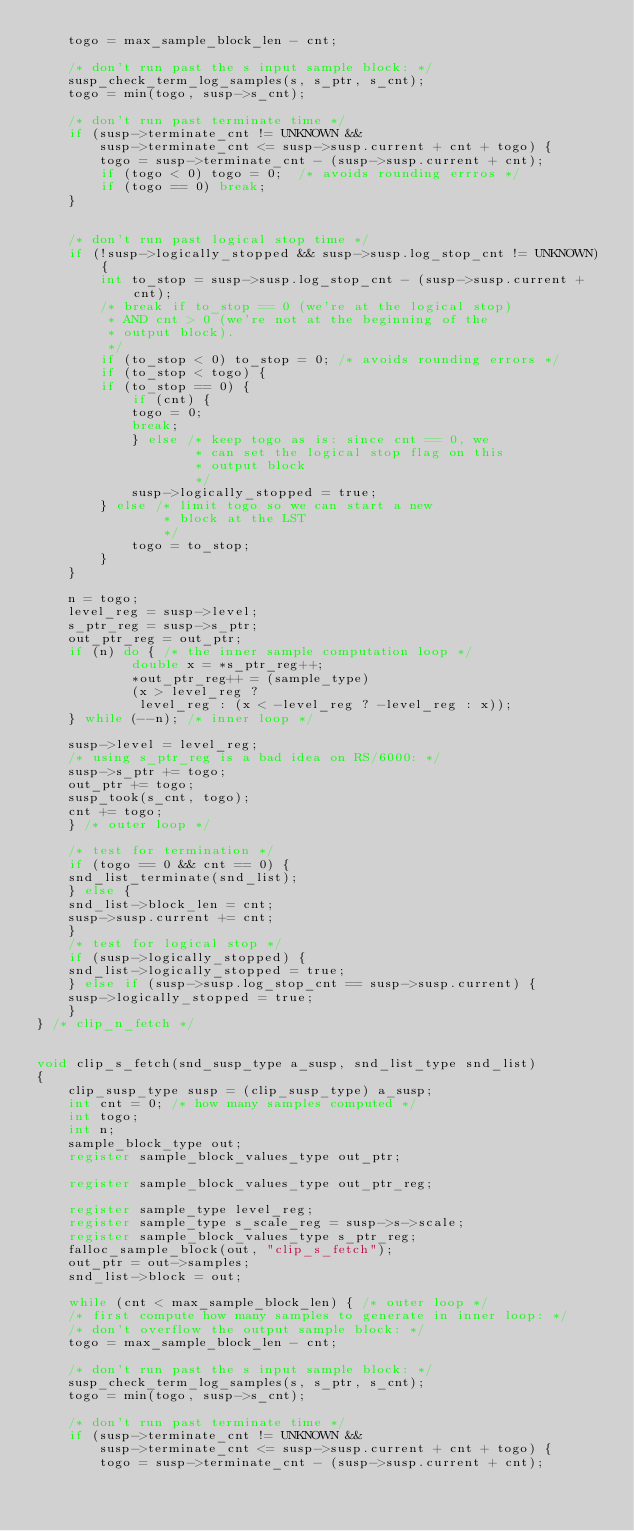Convert code to text. <code><loc_0><loc_0><loc_500><loc_500><_C_>	togo = max_sample_block_len - cnt;

	/* don't run past the s input sample block: */
	susp_check_term_log_samples(s, s_ptr, s_cnt);
	togo = min(togo, susp->s_cnt);

	/* don't run past terminate time */
	if (susp->terminate_cnt != UNKNOWN &&
	    susp->terminate_cnt <= susp->susp.current + cnt + togo) {
	    togo = susp->terminate_cnt - (susp->susp.current + cnt);
	    if (togo < 0) togo = 0;  /* avoids rounding errros */
	    if (togo == 0) break;
	}


	/* don't run past logical stop time */
	if (!susp->logically_stopped && susp->susp.log_stop_cnt != UNKNOWN) {
	    int to_stop = susp->susp.log_stop_cnt - (susp->susp.current + cnt);
	    /* break if to_stop == 0 (we're at the logical stop)
	     * AND cnt > 0 (we're not at the beginning of the
	     * output block).
	     */
	    if (to_stop < 0) to_stop = 0; /* avoids rounding errors */
	    if (to_stop < togo) {
		if (to_stop == 0) {
		    if (cnt) {
			togo = 0;
			break;
		    } else /* keep togo as is: since cnt == 0, we
		            * can set the logical stop flag on this
		            * output block
		            */
			susp->logically_stopped = true;
		} else /* limit togo so we can start a new
		        * block at the LST
		        */
		    togo = to_stop;
	    }
	}

	n = togo;
	level_reg = susp->level;
	s_ptr_reg = susp->s_ptr;
	out_ptr_reg = out_ptr;
	if (n) do { /* the inner sample computation loop */
            double x = *s_ptr_reg++; 
            *out_ptr_reg++ = (sample_type) 
            (x > level_reg ? 
             level_reg : (x < -level_reg ? -level_reg : x));
	} while (--n); /* inner loop */

	susp->level = level_reg;
	/* using s_ptr_reg is a bad idea on RS/6000: */
	susp->s_ptr += togo;
	out_ptr += togo;
	susp_took(s_cnt, togo);
	cnt += togo;
    } /* outer loop */

    /* test for termination */
    if (togo == 0 && cnt == 0) {
	snd_list_terminate(snd_list);
    } else {
	snd_list->block_len = cnt;
	susp->susp.current += cnt;
    }
    /* test for logical stop */
    if (susp->logically_stopped) {
	snd_list->logically_stopped = true;
    } else if (susp->susp.log_stop_cnt == susp->susp.current) {
	susp->logically_stopped = true;
    }
} /* clip_n_fetch */


void clip_s_fetch(snd_susp_type a_susp, snd_list_type snd_list)
{
    clip_susp_type susp = (clip_susp_type) a_susp;
    int cnt = 0; /* how many samples computed */
    int togo;
    int n;
    sample_block_type out;
    register sample_block_values_type out_ptr;

    register sample_block_values_type out_ptr_reg;

    register sample_type level_reg;
    register sample_type s_scale_reg = susp->s->scale;
    register sample_block_values_type s_ptr_reg;
    falloc_sample_block(out, "clip_s_fetch");
    out_ptr = out->samples;
    snd_list->block = out;

    while (cnt < max_sample_block_len) { /* outer loop */
	/* first compute how many samples to generate in inner loop: */
	/* don't overflow the output sample block: */
	togo = max_sample_block_len - cnt;

	/* don't run past the s input sample block: */
	susp_check_term_log_samples(s, s_ptr, s_cnt);
	togo = min(togo, susp->s_cnt);

	/* don't run past terminate time */
	if (susp->terminate_cnt != UNKNOWN &&
	    susp->terminate_cnt <= susp->susp.current + cnt + togo) {
	    togo = susp->terminate_cnt - (susp->susp.current + cnt);</code> 